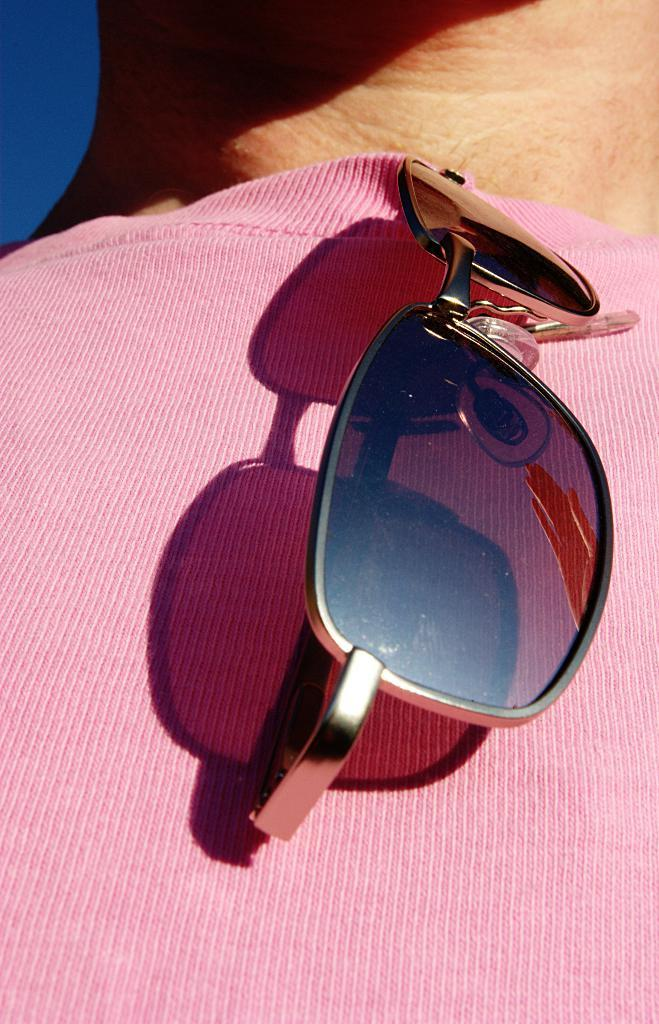What type of eyewear is present in the image? There is a goggle in the image. What color is the t-shirt in the image? There is a pink t-shirt in the image. Where is the nest of the flesh-eating bird in the image? There is no nest or flesh-eating bird present in the image; it only features a goggle and a pink t-shirt. 